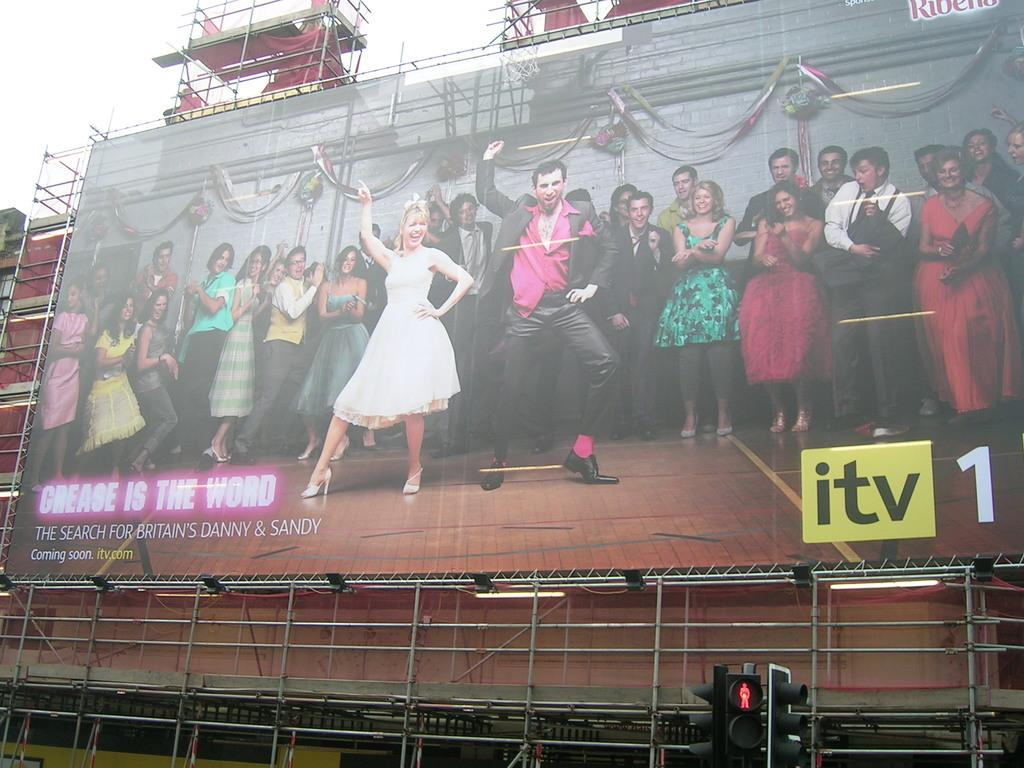<image>
Describe the image concisely. a banner that has the letters itv in the corner 